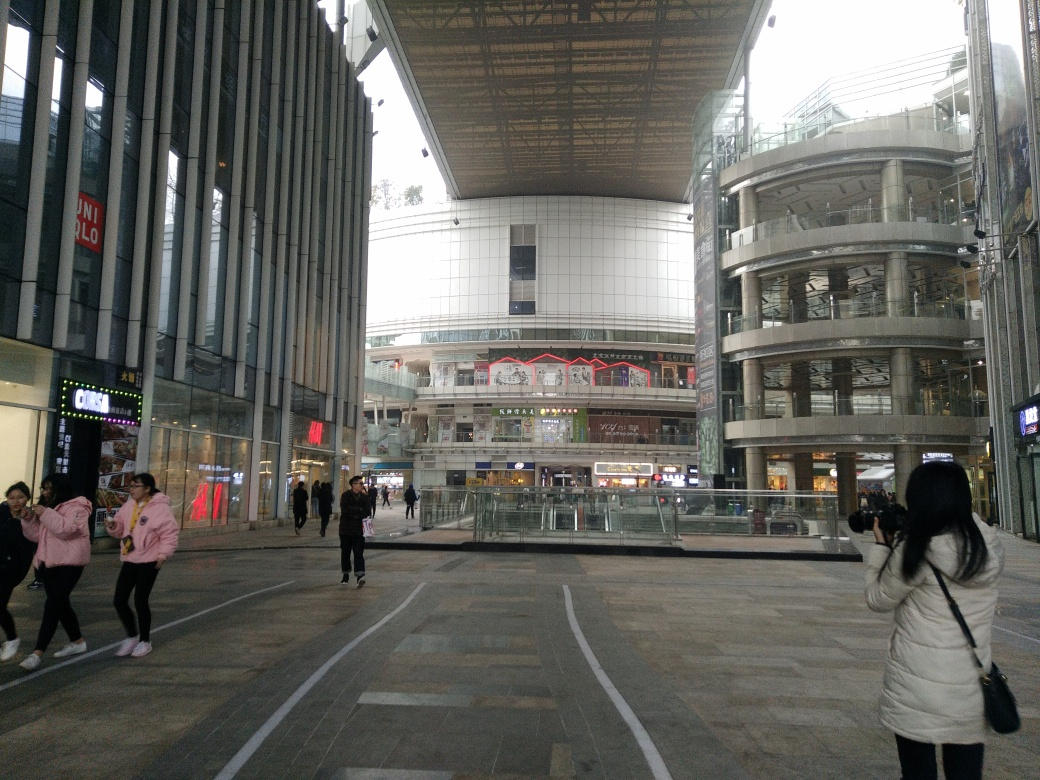Does the photo appear particularly cluttered? While the photo displays various architectural elements and signage which could suggest a degree of busyness, the open space in the foreground and orderly arrangement of structures provide a sense of organization. Thus, it doesn't appear particularly cluttered, but rather moderately busy, which is expected in an urban shopping area. 